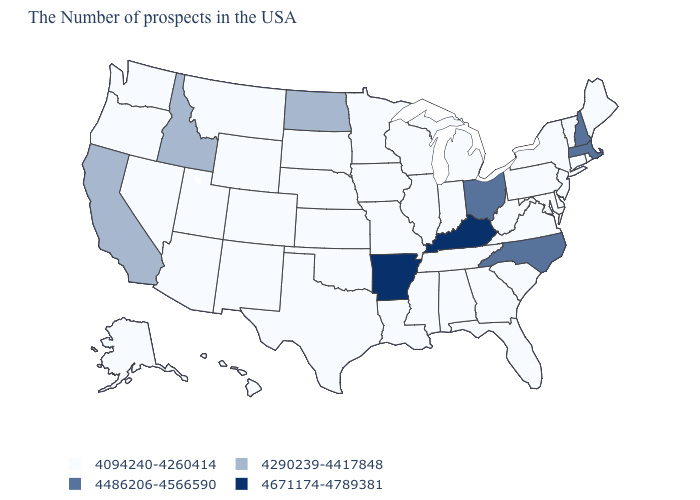What is the value of Colorado?
Answer briefly. 4094240-4260414. Which states have the lowest value in the South?
Concise answer only. Delaware, Maryland, Virginia, South Carolina, West Virginia, Florida, Georgia, Alabama, Tennessee, Mississippi, Louisiana, Oklahoma, Texas. What is the value of Hawaii?
Answer briefly. 4094240-4260414. What is the value of Delaware?
Give a very brief answer. 4094240-4260414. Does Georgia have the same value as Connecticut?
Write a very short answer. Yes. Is the legend a continuous bar?
Quick response, please. No. Does the first symbol in the legend represent the smallest category?
Short answer required. Yes. Name the states that have a value in the range 4486206-4566590?
Answer briefly. Massachusetts, New Hampshire, North Carolina, Ohio. What is the value of Mississippi?
Keep it brief. 4094240-4260414. How many symbols are there in the legend?
Concise answer only. 4. What is the value of New York?
Keep it brief. 4094240-4260414. What is the value of Indiana?
Concise answer only. 4094240-4260414. Does Georgia have the lowest value in the South?
Concise answer only. Yes. Does North Dakota have the lowest value in the USA?
Write a very short answer. No. 